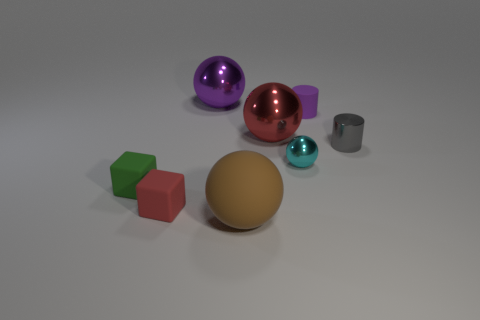Add 2 small yellow rubber cubes. How many objects exist? 10 Subtract all small metal balls. How many balls are left? 3 Subtract all cubes. How many objects are left? 6 Subtract all tiny red matte things. Subtract all tiny green matte things. How many objects are left? 6 Add 2 green blocks. How many green blocks are left? 3 Add 8 big gray metallic things. How many big gray metallic things exist? 8 Subtract all green cubes. How many cubes are left? 1 Subtract 0 gray blocks. How many objects are left? 8 Subtract all gray cylinders. Subtract all brown balls. How many cylinders are left? 1 Subtract all cyan spheres. How many purple cylinders are left? 1 